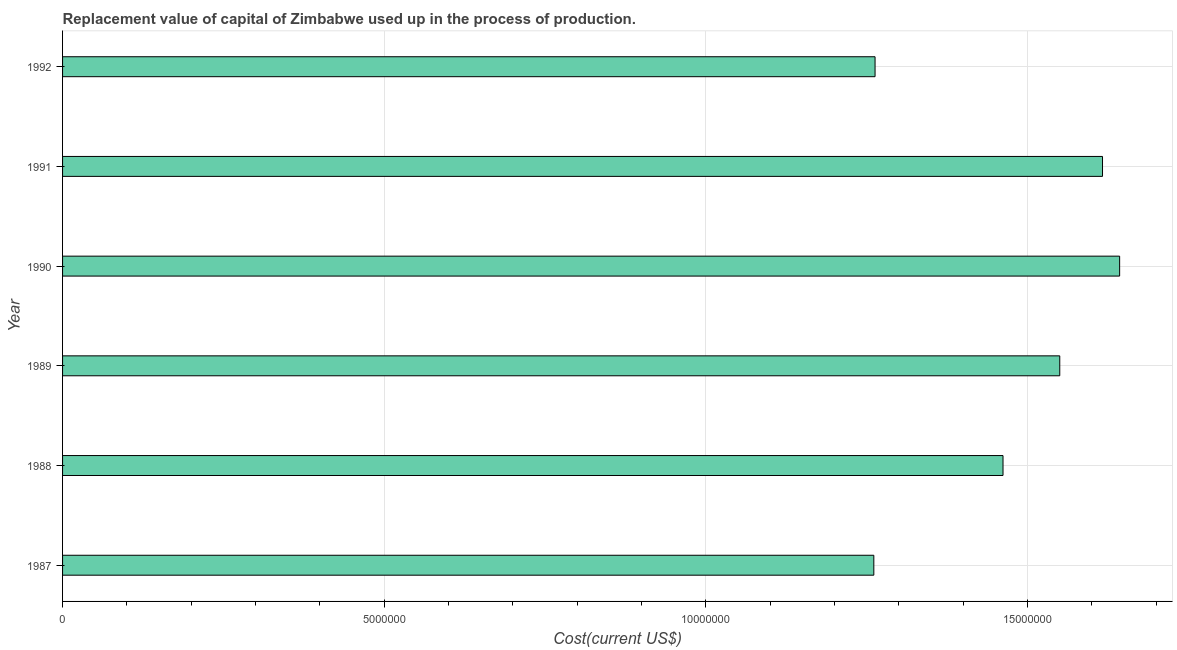Does the graph contain grids?
Keep it short and to the point. Yes. What is the title of the graph?
Provide a short and direct response. Replacement value of capital of Zimbabwe used up in the process of production. What is the label or title of the X-axis?
Ensure brevity in your answer.  Cost(current US$). What is the label or title of the Y-axis?
Your answer should be very brief. Year. What is the consumption of fixed capital in 1991?
Provide a succinct answer. 1.62e+07. Across all years, what is the maximum consumption of fixed capital?
Offer a very short reply. 1.64e+07. Across all years, what is the minimum consumption of fixed capital?
Your response must be concise. 1.26e+07. In which year was the consumption of fixed capital minimum?
Your answer should be compact. 1987. What is the sum of the consumption of fixed capital?
Your answer should be very brief. 8.80e+07. What is the difference between the consumption of fixed capital in 1987 and 1988?
Your answer should be compact. -2.01e+06. What is the average consumption of fixed capital per year?
Your answer should be very brief. 1.47e+07. What is the median consumption of fixed capital?
Your response must be concise. 1.51e+07. In how many years, is the consumption of fixed capital greater than 12000000 US$?
Provide a short and direct response. 6. What is the ratio of the consumption of fixed capital in 1987 to that in 1991?
Your answer should be very brief. 0.78. Is the difference between the consumption of fixed capital in 1990 and 1992 greater than the difference between any two years?
Provide a short and direct response. No. What is the difference between the highest and the second highest consumption of fixed capital?
Give a very brief answer. 2.66e+05. Is the sum of the consumption of fixed capital in 1989 and 1990 greater than the maximum consumption of fixed capital across all years?
Your response must be concise. Yes. What is the difference between the highest and the lowest consumption of fixed capital?
Provide a succinct answer. 3.82e+06. Are all the bars in the graph horizontal?
Provide a succinct answer. Yes. How many years are there in the graph?
Your answer should be very brief. 6. Are the values on the major ticks of X-axis written in scientific E-notation?
Offer a very short reply. No. What is the Cost(current US$) in 1987?
Your response must be concise. 1.26e+07. What is the Cost(current US$) in 1988?
Ensure brevity in your answer.  1.46e+07. What is the Cost(current US$) of 1989?
Give a very brief answer. 1.55e+07. What is the Cost(current US$) of 1990?
Keep it short and to the point. 1.64e+07. What is the Cost(current US$) of 1991?
Provide a succinct answer. 1.62e+07. What is the Cost(current US$) of 1992?
Your response must be concise. 1.26e+07. What is the difference between the Cost(current US$) in 1987 and 1988?
Ensure brevity in your answer.  -2.01e+06. What is the difference between the Cost(current US$) in 1987 and 1989?
Offer a very short reply. -2.89e+06. What is the difference between the Cost(current US$) in 1987 and 1990?
Your answer should be very brief. -3.82e+06. What is the difference between the Cost(current US$) in 1987 and 1991?
Your answer should be compact. -3.55e+06. What is the difference between the Cost(current US$) in 1987 and 1992?
Make the answer very short. -1.92e+04. What is the difference between the Cost(current US$) in 1988 and 1989?
Your response must be concise. -8.82e+05. What is the difference between the Cost(current US$) in 1988 and 1990?
Offer a very short reply. -1.81e+06. What is the difference between the Cost(current US$) in 1988 and 1991?
Make the answer very short. -1.55e+06. What is the difference between the Cost(current US$) in 1988 and 1992?
Ensure brevity in your answer.  1.99e+06. What is the difference between the Cost(current US$) in 1989 and 1990?
Ensure brevity in your answer.  -9.31e+05. What is the difference between the Cost(current US$) in 1989 and 1991?
Provide a short and direct response. -6.64e+05. What is the difference between the Cost(current US$) in 1989 and 1992?
Your response must be concise. 2.87e+06. What is the difference between the Cost(current US$) in 1990 and 1991?
Provide a succinct answer. 2.66e+05. What is the difference between the Cost(current US$) in 1990 and 1992?
Provide a succinct answer. 3.80e+06. What is the difference between the Cost(current US$) in 1991 and 1992?
Provide a short and direct response. 3.54e+06. What is the ratio of the Cost(current US$) in 1987 to that in 1988?
Your answer should be compact. 0.86. What is the ratio of the Cost(current US$) in 1987 to that in 1989?
Ensure brevity in your answer.  0.81. What is the ratio of the Cost(current US$) in 1987 to that in 1990?
Give a very brief answer. 0.77. What is the ratio of the Cost(current US$) in 1987 to that in 1991?
Your answer should be very brief. 0.78. What is the ratio of the Cost(current US$) in 1987 to that in 1992?
Provide a succinct answer. 1. What is the ratio of the Cost(current US$) in 1988 to that in 1989?
Offer a terse response. 0.94. What is the ratio of the Cost(current US$) in 1988 to that in 1990?
Offer a very short reply. 0.89. What is the ratio of the Cost(current US$) in 1988 to that in 1991?
Make the answer very short. 0.9. What is the ratio of the Cost(current US$) in 1988 to that in 1992?
Give a very brief answer. 1.16. What is the ratio of the Cost(current US$) in 1989 to that in 1990?
Offer a very short reply. 0.94. What is the ratio of the Cost(current US$) in 1989 to that in 1992?
Offer a terse response. 1.23. What is the ratio of the Cost(current US$) in 1990 to that in 1991?
Offer a terse response. 1.02. What is the ratio of the Cost(current US$) in 1990 to that in 1992?
Provide a short and direct response. 1.3. What is the ratio of the Cost(current US$) in 1991 to that in 1992?
Provide a short and direct response. 1.28. 